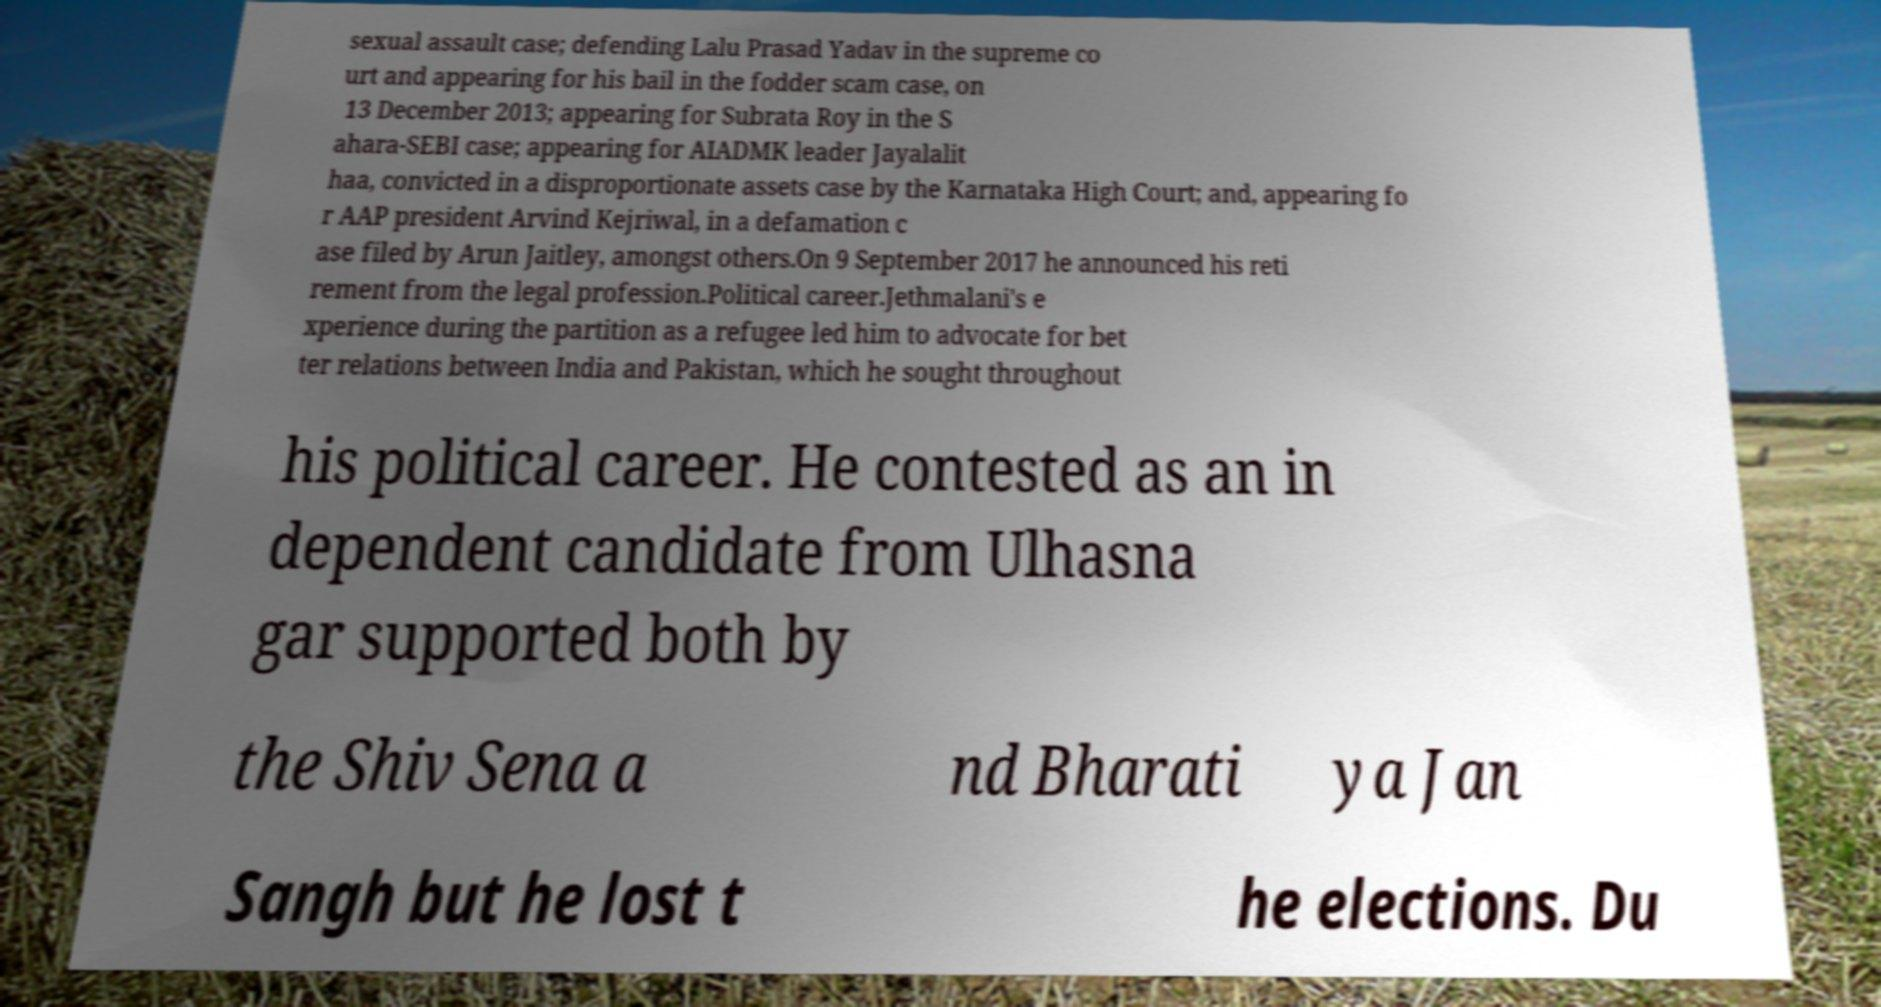Could you extract and type out the text from this image? sexual assault case; defending Lalu Prasad Yadav in the supreme co urt and appearing for his bail in the fodder scam case, on 13 December 2013; appearing for Subrata Roy in the S ahara-SEBI case; appearing for AIADMK leader Jayalalit haa, convicted in a disproportionate assets case by the Karnataka High Court; and, appearing fo r AAP president Arvind Kejriwal, in a defamation c ase filed by Arun Jaitley, amongst others.On 9 September 2017 he announced his reti rement from the legal profession.Political career.Jethmalani's e xperience during the partition as a refugee led him to advocate for bet ter relations between India and Pakistan, which he sought throughout his political career. He contested as an in dependent candidate from Ulhasna gar supported both by the Shiv Sena a nd Bharati ya Jan Sangh but he lost t he elections. Du 